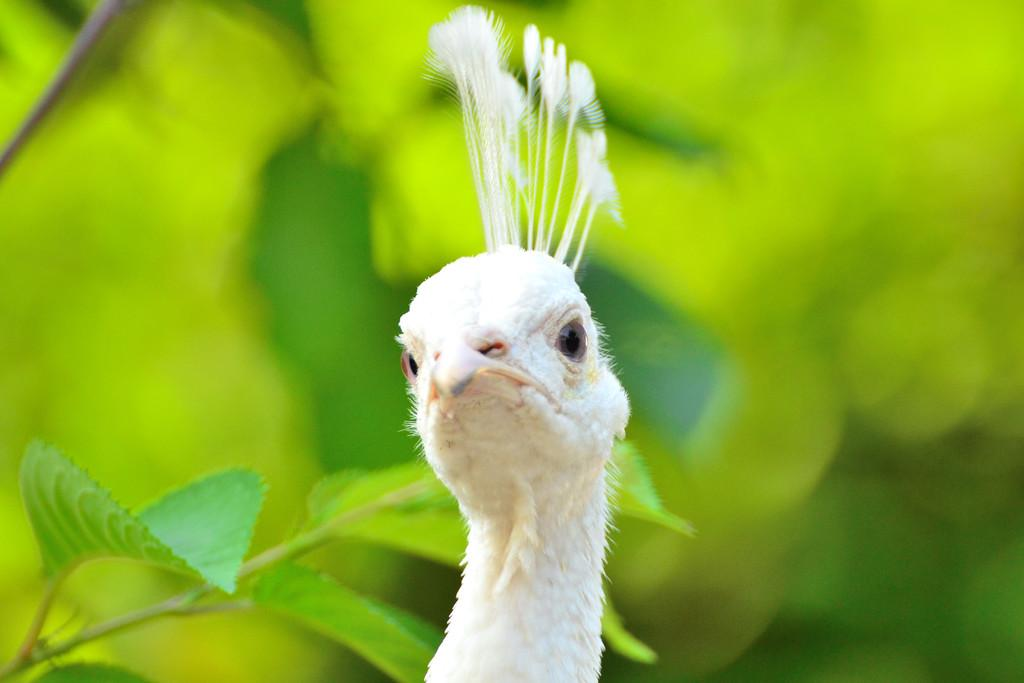What is the main subject of the image? The main subject of the image is a peacock's head. What color is the peacock's head in the image? The peacock's head is white in color. What can be seen on the left side of the image? There are leaves of a tree on the left side of the image. How many holes can be seen in the peacock's head in the image? There are no holes visible in the peacock's head in the image. What type of truck is parked behind the tree in the image? There is no truck present in the image; it only features a peacock's head and leaves from a tree. 